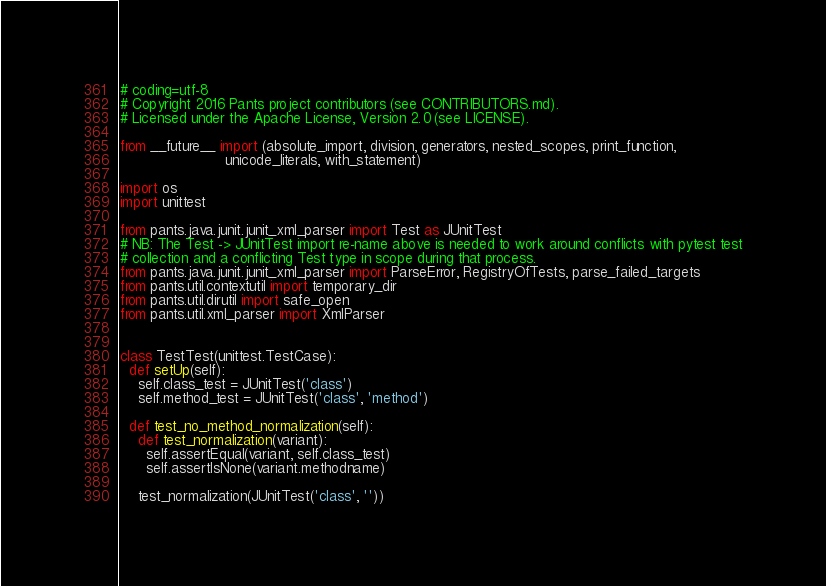<code> <loc_0><loc_0><loc_500><loc_500><_Python_># coding=utf-8
# Copyright 2016 Pants project contributors (see CONTRIBUTORS.md).
# Licensed under the Apache License, Version 2.0 (see LICENSE).

from __future__ import (absolute_import, division, generators, nested_scopes, print_function,
                        unicode_literals, with_statement)

import os
import unittest

from pants.java.junit.junit_xml_parser import Test as JUnitTest
# NB: The Test -> JUnitTest import re-name above is needed to work around conflicts with pytest test
# collection and a conflicting Test type in scope during that process.
from pants.java.junit.junit_xml_parser import ParseError, RegistryOfTests, parse_failed_targets
from pants.util.contextutil import temporary_dir
from pants.util.dirutil import safe_open
from pants.util.xml_parser import XmlParser


class TestTest(unittest.TestCase):
  def setUp(self):
    self.class_test = JUnitTest('class')
    self.method_test = JUnitTest('class', 'method')

  def test_no_method_normalization(self):
    def test_normalization(variant):
      self.assertEqual(variant, self.class_test)
      self.assertIsNone(variant.methodname)

    test_normalization(JUnitTest('class', ''))</code> 